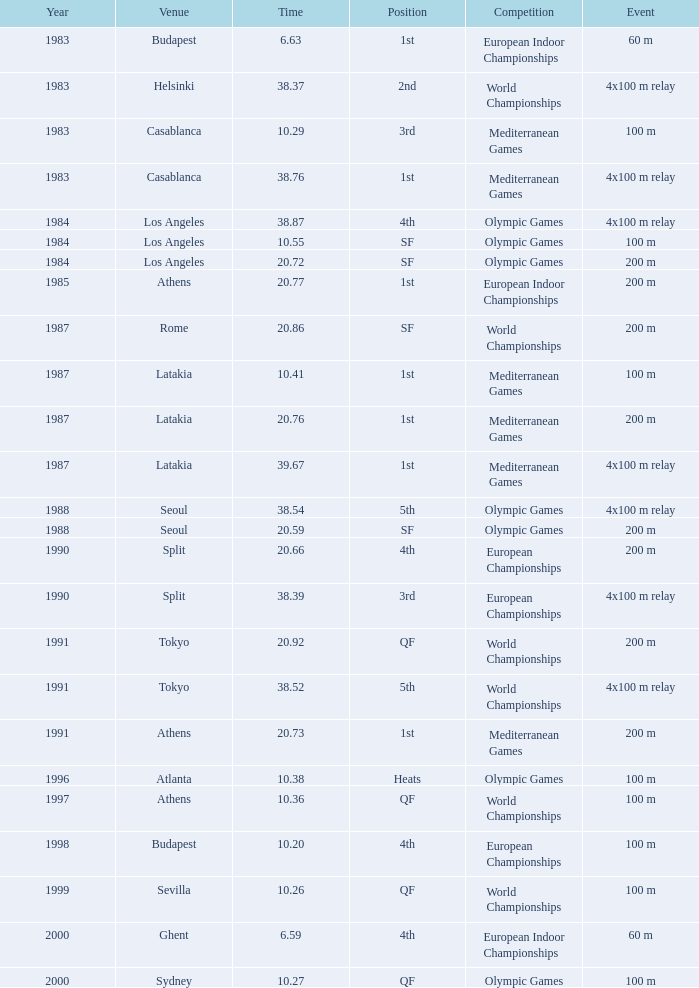What Event has a Position of 1st, a Year of 1983, and a Venue of budapest? 60 m. 